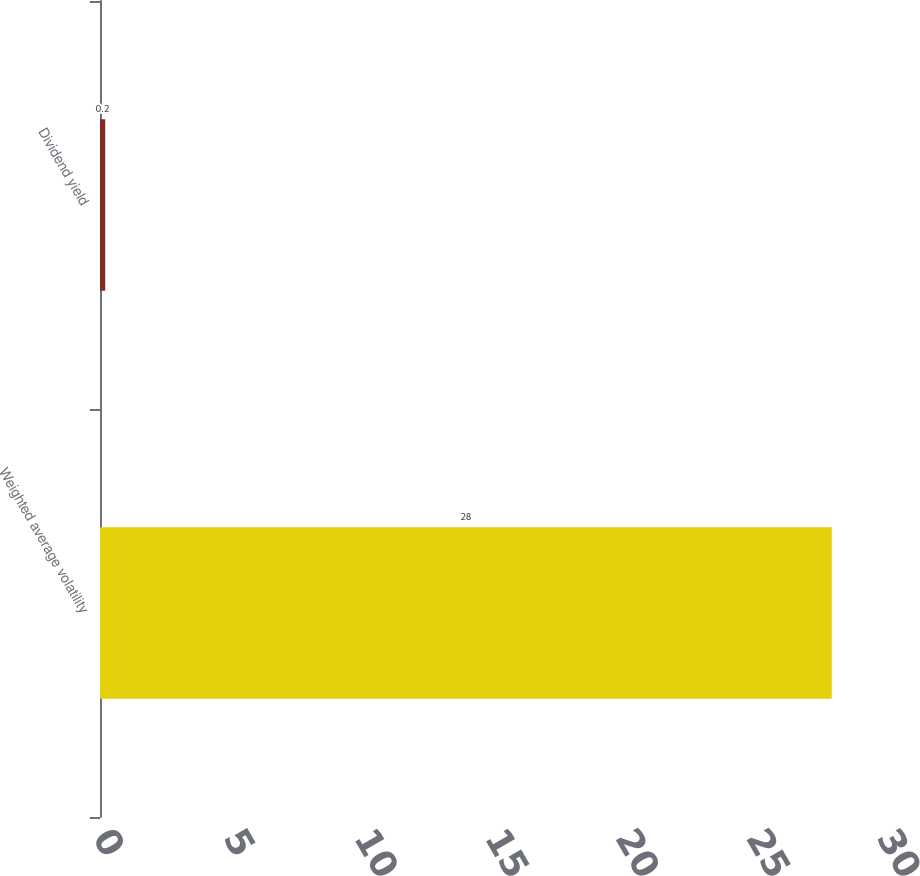Convert chart to OTSL. <chart><loc_0><loc_0><loc_500><loc_500><bar_chart><fcel>Weighted average volatility<fcel>Dividend yield<nl><fcel>28<fcel>0.2<nl></chart> 